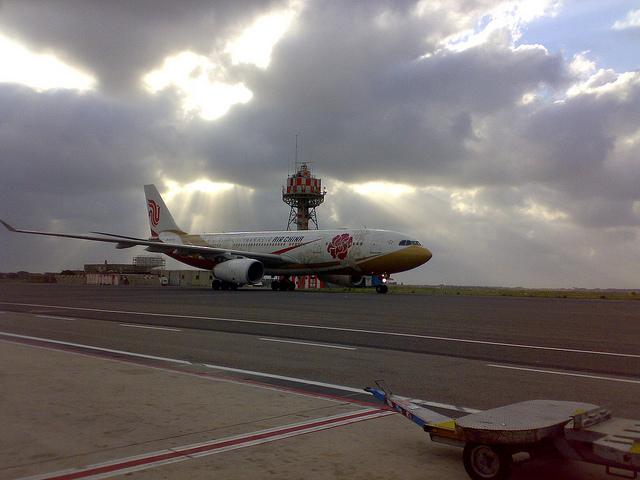What is the picture on the side of the plane?
Short answer required. Flower. What's blocking the clouds?
Quick response, please. Plane. Where was this picture taken?
Be succinct. Airport. Is the plane taking off?
Concise answer only. No. Is the airplane facing left or right in this scene?
Be succinct. Right. 